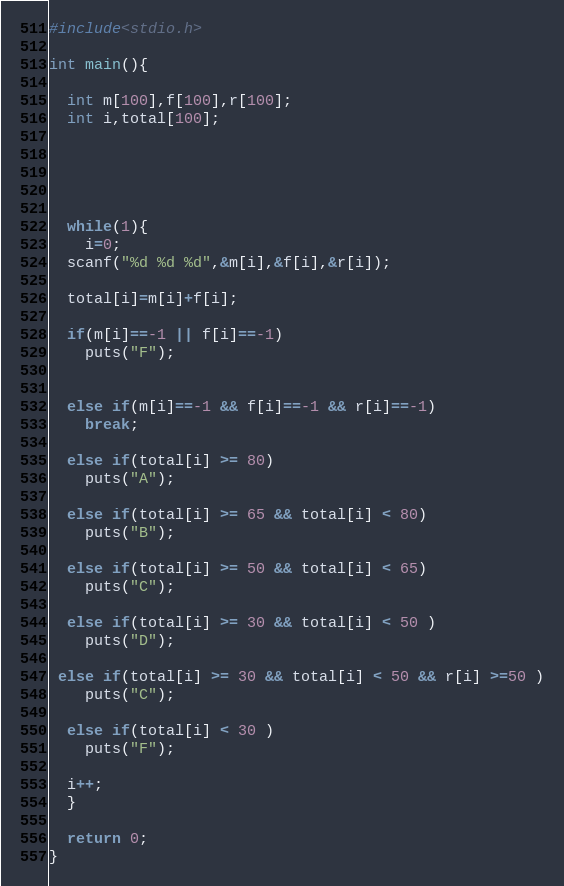Convert code to text. <code><loc_0><loc_0><loc_500><loc_500><_C_>#include<stdio.h>

int main(){

  int m[100],f[100],r[100];
  int i,total[100];





  while(1){
    i=0;
  scanf("%d %d %d",&m[i],&f[i],&r[i]);

  total[i]=m[i]+f[i];

  if(m[i]==-1 || f[i]==-1)
    puts("F");


  else if(m[i]==-1 && f[i]==-1 && r[i]==-1)
    break;

  else if(total[i] >= 80)
    puts("A");

  else if(total[i] >= 65 && total[i] < 80)
    puts("B");

  else if(total[i] >= 50 && total[i] < 65)
    puts("C");

  else if(total[i] >= 30 && total[i] < 50 )
    puts("D");

 else if(total[i] >= 30 && total[i] < 50 && r[i] >=50 )
    puts("C");

  else if(total[i] < 30 )
    puts("F");

  i++;
  }

  return 0;
}</code> 